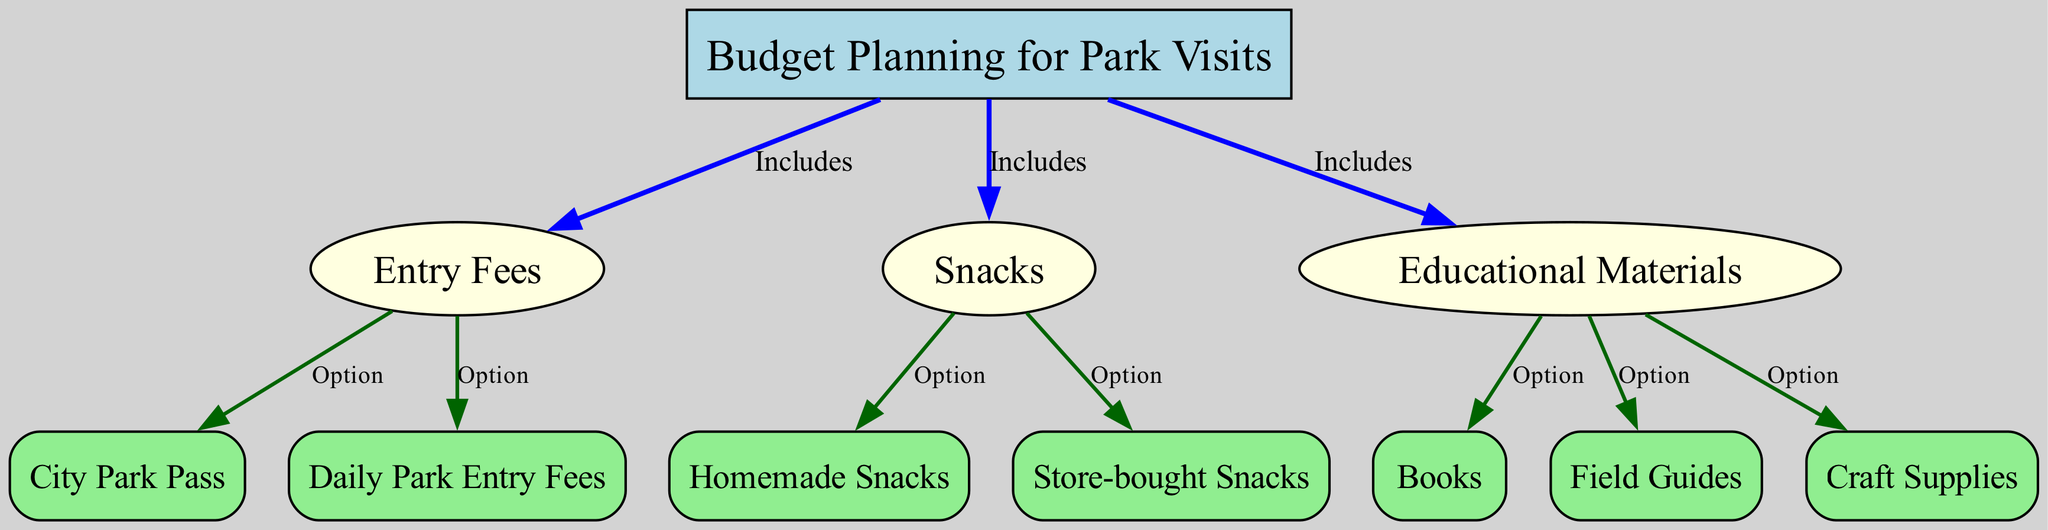What is the main topic of the diagram? The main topic is indicated by the top node labeled "Budget Planning for Park Visits," which serves as the central theme of the diagram.
Answer: Budget Planning for Park Visits How many main categories are included in the budget? The diagram includes three main categories: Entry Fees, Snacks, and Educational Materials. Each is represented as a node branching from the main topic.
Answer: Three What is one of the options under Entry Fees? The diagram shows that "Daily Park Entry Fees" and "City Park Pass" are both options available under the Entry Fees category.
Answer: City Park Pass Which type of snacks can be homemade? The diagram labels "Homemade Snacks" as an option under Snacks, indicating that this type of snack can be made at home rather than being store-bought.
Answer: Homemade Snacks What educational material option is related to nature? The option "Field Guides" under Educational Materials implies that this is a type of educational material specifically related to nature, helping identify plants, animals, etc.
Answer: Field Guides How does the Entry Fees node relate to the Budget Planning node? The Entry Fees node is directly connected to the Budget Planning node, indicating it is a category that is included in the overall budget planning for park visits.
Answer: Includes What are the number of sub-options listed under Educational Materials? The diagram shows three sub-options under Educational Materials: Books, Field Guides, and Craft Supplies. This indicates a variety of choices for educational materials.
Answer: Three What is the color of the node representing Edible Snacks? The Snacks node and its sub-options, such as Homemade Snacks and Store-bought Snacks, are represented by light yellow-colored nodes, distinguishing them from other categories in the diagram.
Answer: Light yellow How is the relationship between Educational Materials and its options described? The relationship is indicated by the edges with a label "Option," showing that all items under Educational Materials are considered options within that category.
Answer: Option 